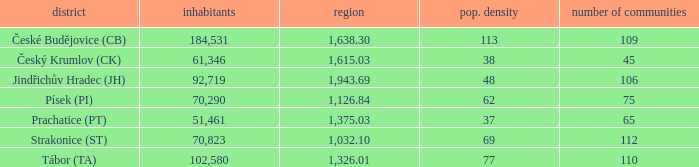Help me parse the entirety of this table. {'header': ['district', 'inhabitants', 'region', 'pop. density', 'number of communities'], 'rows': [['České Budějovice (CB)', '184,531', '1,638.30', '113', '109'], ['Český Krumlov (CK)', '61,346', '1,615.03', '38', '45'], ['Jindřichův Hradec (JH)', '92,719', '1,943.69', '48', '106'], ['Písek (PI)', '70,290', '1,126.84', '62', '75'], ['Prachatice (PT)', '51,461', '1,375.03', '37', '65'], ['Strakonice (ST)', '70,823', '1,032.10', '69', '112'], ['Tábor (TA)', '102,580', '1,326.01', '77', '110']]} What is the population density of the area with a population larger than 92,719? 2.0. 